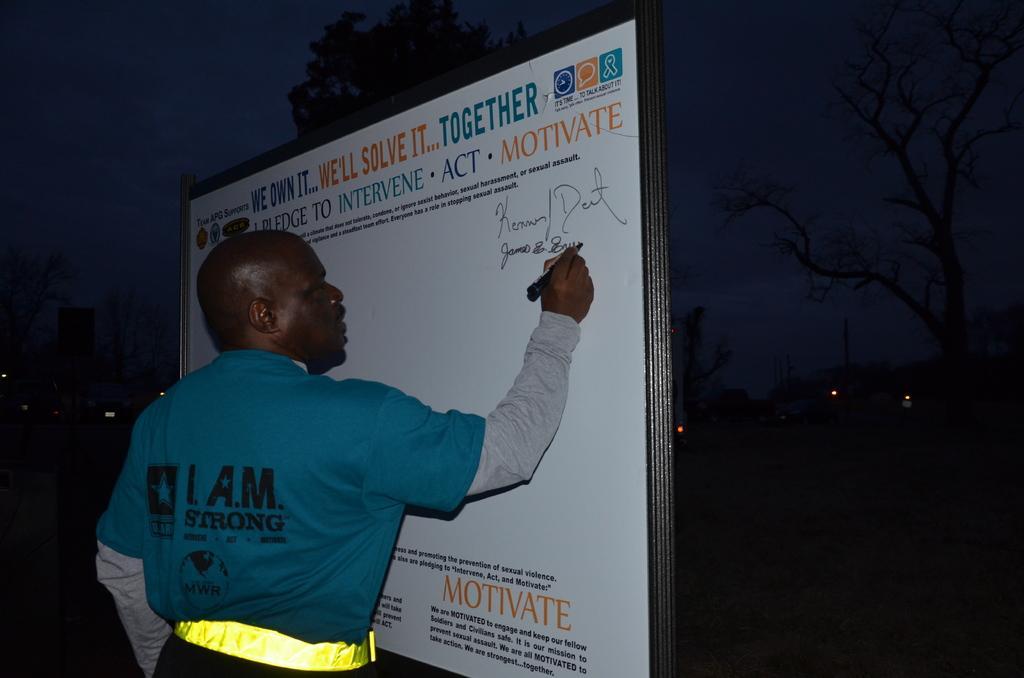Please provide a concise description of this image. In center of the picture there is a person writing on the board, on the board there is text. In the background there are trees and lights. Sky is dark. 